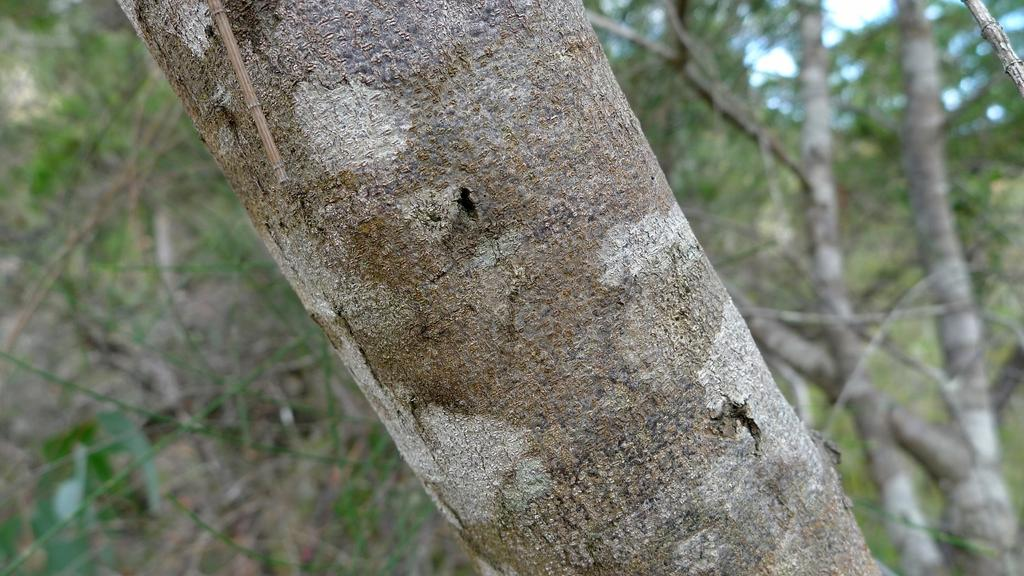What type of vegetation can be seen in the image? There are trees in the image. Can you describe any specific part of the trees? There is a tree trunk in the image. How would you describe the overall appearance of the image? The background of the image is blurred. What type of cream is being used to treat the disease in the image? There is no mention of cream or disease in the image; it features trees and a tree trunk with a blurred background. 